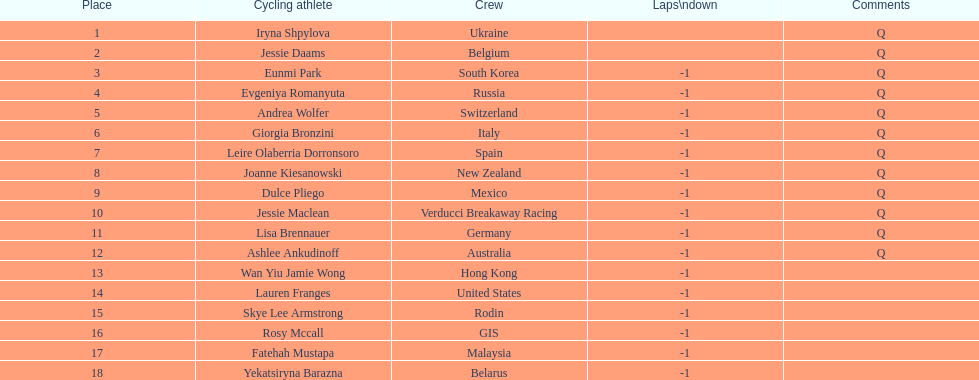How many cyclist do not have -1 laps down? 2. 